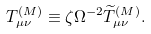Convert formula to latex. <formula><loc_0><loc_0><loc_500><loc_500>T _ { \mu \nu } ^ { ( M ) } \equiv \zeta \Omega ^ { - 2 } \widetilde { T } _ { \mu \nu } ^ { ( M ) } .</formula> 